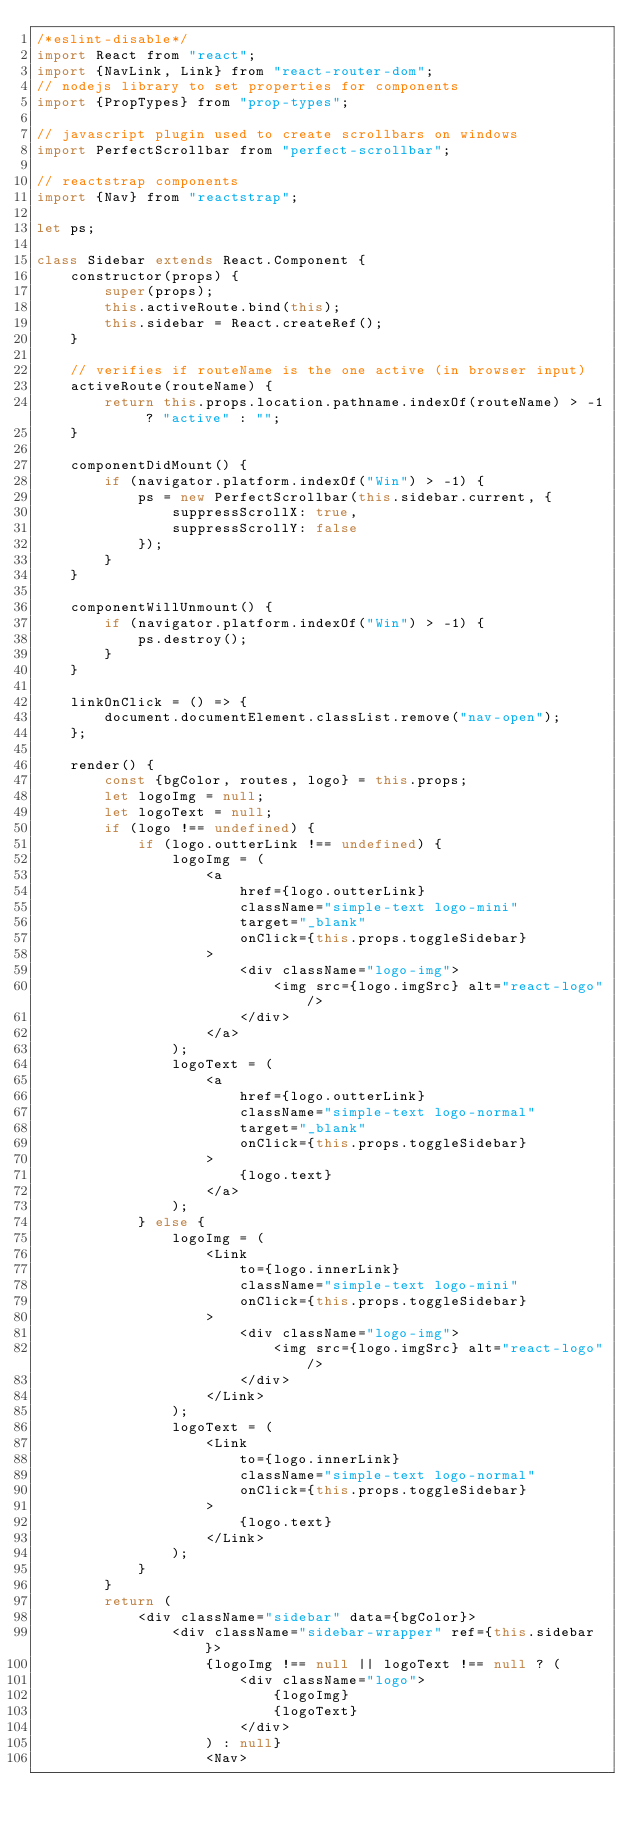<code> <loc_0><loc_0><loc_500><loc_500><_JavaScript_>/*eslint-disable*/
import React from "react";
import {NavLink, Link} from "react-router-dom";
// nodejs library to set properties for components
import {PropTypes} from "prop-types";

// javascript plugin used to create scrollbars on windows
import PerfectScrollbar from "perfect-scrollbar";

// reactstrap components
import {Nav} from "reactstrap";

let ps;

class Sidebar extends React.Component {
    constructor(props) {
        super(props);
        this.activeRoute.bind(this);
        this.sidebar = React.createRef();
    }

    // verifies if routeName is the one active (in browser input)
    activeRoute(routeName) {
        return this.props.location.pathname.indexOf(routeName) > -1 ? "active" : "";
    }

    componentDidMount() {
        if (navigator.platform.indexOf("Win") > -1) {
            ps = new PerfectScrollbar(this.sidebar.current, {
                suppressScrollX: true,
                suppressScrollY: false
            });
        }
    }

    componentWillUnmount() {
        if (navigator.platform.indexOf("Win") > -1) {
            ps.destroy();
        }
    }

    linkOnClick = () => {
        document.documentElement.classList.remove("nav-open");
    };

    render() {
        const {bgColor, routes, logo} = this.props;
        let logoImg = null;
        let logoText = null;
        if (logo !== undefined) {
            if (logo.outterLink !== undefined) {
                logoImg = (
                    <a
                        href={logo.outterLink}
                        className="simple-text logo-mini"
                        target="_blank"
                        onClick={this.props.toggleSidebar}
                    >
                        <div className="logo-img">
                            <img src={logo.imgSrc} alt="react-logo"/>
                        </div>
                    </a>
                );
                logoText = (
                    <a
                        href={logo.outterLink}
                        className="simple-text logo-normal"
                        target="_blank"
                        onClick={this.props.toggleSidebar}
                    >
                        {logo.text}
                    </a>
                );
            } else {
                logoImg = (
                    <Link
                        to={logo.innerLink}
                        className="simple-text logo-mini"
                        onClick={this.props.toggleSidebar}
                    >
                        <div className="logo-img">
                            <img src={logo.imgSrc} alt="react-logo"/>
                        </div>
                    </Link>
                );
                logoText = (
                    <Link
                        to={logo.innerLink}
                        className="simple-text logo-normal"
                        onClick={this.props.toggleSidebar}
                    >
                        {logo.text}
                    </Link>
                );
            }
        }
        return (
            <div className="sidebar" data={bgColor}>
                <div className="sidebar-wrapper" ref={this.sidebar}>
                    {logoImg !== null || logoText !== null ? (
                        <div className="logo">
                            {logoImg}
                            {logoText}
                        </div>
                    ) : null}
                    <Nav></code> 